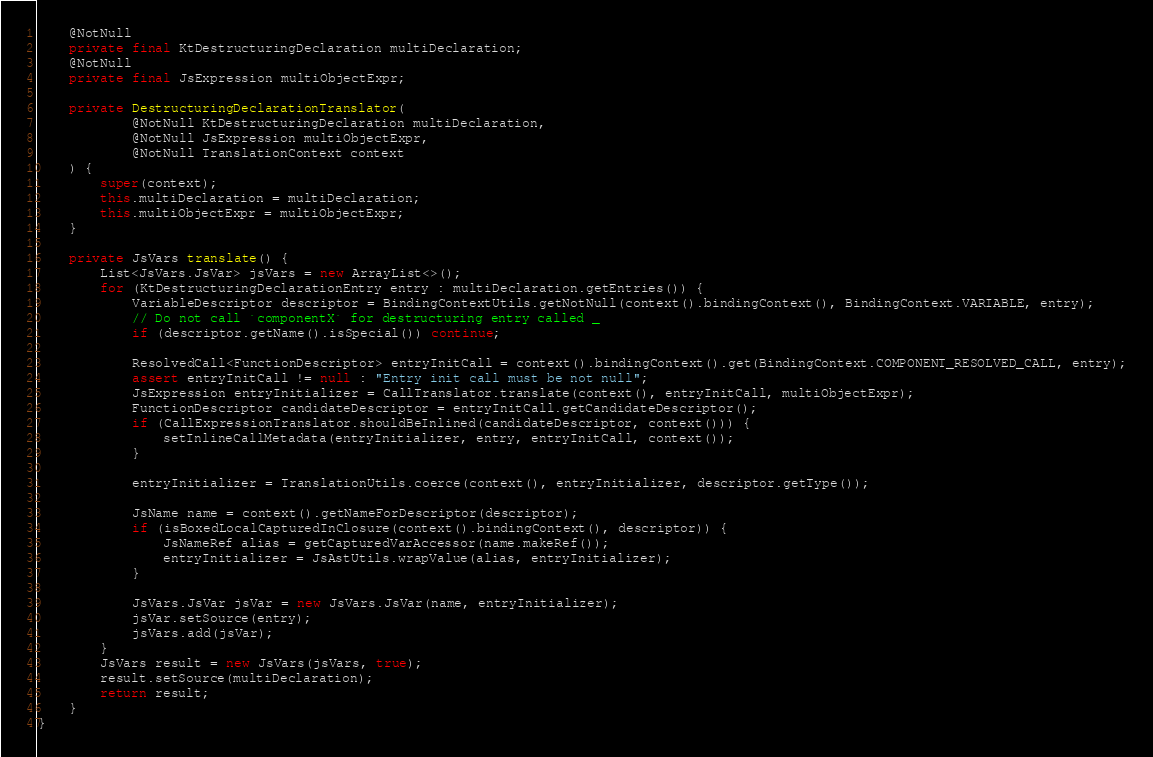<code> <loc_0><loc_0><loc_500><loc_500><_Java_>
    @NotNull
    private final KtDestructuringDeclaration multiDeclaration;
    @NotNull
    private final JsExpression multiObjectExpr;

    private DestructuringDeclarationTranslator(
            @NotNull KtDestructuringDeclaration multiDeclaration,
            @NotNull JsExpression multiObjectExpr,
            @NotNull TranslationContext context
    ) {
        super(context);
        this.multiDeclaration = multiDeclaration;
        this.multiObjectExpr = multiObjectExpr;
    }

    private JsVars translate() {
        List<JsVars.JsVar> jsVars = new ArrayList<>();
        for (KtDestructuringDeclarationEntry entry : multiDeclaration.getEntries()) {
            VariableDescriptor descriptor = BindingContextUtils.getNotNull(context().bindingContext(), BindingContext.VARIABLE, entry);
            // Do not call `componentX` for destructuring entry called _
            if (descriptor.getName().isSpecial()) continue;

            ResolvedCall<FunctionDescriptor> entryInitCall = context().bindingContext().get(BindingContext.COMPONENT_RESOLVED_CALL, entry);
            assert entryInitCall != null : "Entry init call must be not null";
            JsExpression entryInitializer = CallTranslator.translate(context(), entryInitCall, multiObjectExpr);
            FunctionDescriptor candidateDescriptor = entryInitCall.getCandidateDescriptor();
            if (CallExpressionTranslator.shouldBeInlined(candidateDescriptor, context())) {
                setInlineCallMetadata(entryInitializer, entry, entryInitCall, context());
            }

            entryInitializer = TranslationUtils.coerce(context(), entryInitializer, descriptor.getType());

            JsName name = context().getNameForDescriptor(descriptor);
            if (isBoxedLocalCapturedInClosure(context().bindingContext(), descriptor)) {
                JsNameRef alias = getCapturedVarAccessor(name.makeRef());
                entryInitializer = JsAstUtils.wrapValue(alias, entryInitializer);
            }

            JsVars.JsVar jsVar = new JsVars.JsVar(name, entryInitializer);
            jsVar.setSource(entry);
            jsVars.add(jsVar);
        }
        JsVars result = new JsVars(jsVars, true);
        result.setSource(multiDeclaration);
        return result;
    }
}
</code> 